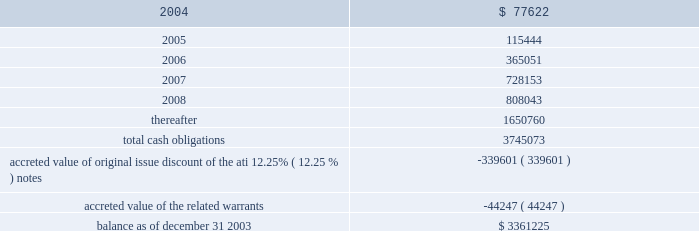American tower corporation and subsidiaries notes to consolidated financial statements 2014 ( continued ) maturities 2014as of december 31 , 2003 , aggregate principal payments of long-term debt , including capital leases , for the next five years and thereafter are estimated to be ( in thousands ) : year ending december 31 .
The holders of the company 2019s convertible notes have the right to require the company to repurchase their notes on specified dates prior to their maturity dates in 2009 and 2010 , but the company may pay the purchase price by issuing shares of class a common stock , subject to certain conditions .
Obligations with respect to the right of the holders to put the 6.25% ( 6.25 % ) notes and 5.0% ( 5.0 % ) notes have been included in the table above as if such notes mature on the date of their put rights in 2006 and 2007 , respectively .
( see note 19. ) 8 .
Derivative financial instruments under the terms of the credit facilities , the company is required to enter into interest rate protection agreements on at least 50% ( 50 % ) of its variable rate debt .
Under these agreements , the company is exposed to credit risk to the extent that a counterparty fails to meet the terms of a contract .
Such exposure is limited to the current value of the contract at the time the counterparty fails to perform .
The company believes its contracts as of december 31 , 2003 are with credit worthy institutions .
As of december 31 , 2003 , the company had three interest rate caps outstanding that include an aggregate notional amount of $ 500.0 million ( each at an interest rate of 5% ( 5 % ) ) and expire in 2004 .
As of december 31 , 2003 and 2002 , liabilities related to derivative financial instruments of $ 0.0 million and $ 15.5 million are reflected in other long-term liabilities in the accompanying consolidated balance sheet .
During the year ended december 31 , 2003 , the company recorded an unrealized loss of approximately $ 0.3 million ( net of a tax benefit of approximately $ 0.2 million ) in other comprehensive loss for the change in fair value of cash flow hedges and reclassified $ 5.9 million ( net of a tax benefit of approximately $ 3.2 million ) into results of operations .
During the year ended december 31 , 2002 , the company recorded an unrealized loss of approximately $ 9.1 million ( net of a tax benefit of approximately $ 4.9 million ) in other comprehensive loss for the change in fair value of cash flow hedges and reclassified $ 19.5 million ( net of a tax benefit of approximately $ 10.5 million ) into results of operations .
Hedge ineffectiveness resulted in a gain of approximately $ 1.0 million and a loss of approximately $ 2.2 million for the years ended december 31 , 2002 and 2001 , respectively , which are recorded in loss on investments and other expense in the accompanying consolidated statements of operations for those periods .
The company records the changes in fair value of its derivative instruments that are not accounted for as hedges in loss on investments and other expense .
The company does not anticipate reclassifying any derivative losses into its statement of operations within the next twelve months , as there are no amounts included in other comprehensive loss as of december 31 , 2003. .
What will be the balance of aggregate principal payments of long-term debt as of december 31 , 2005 , assuming that no new debt is issued? 
Computations: ((3361225 - 77622) - 115444)
Answer: 3168159.0. 